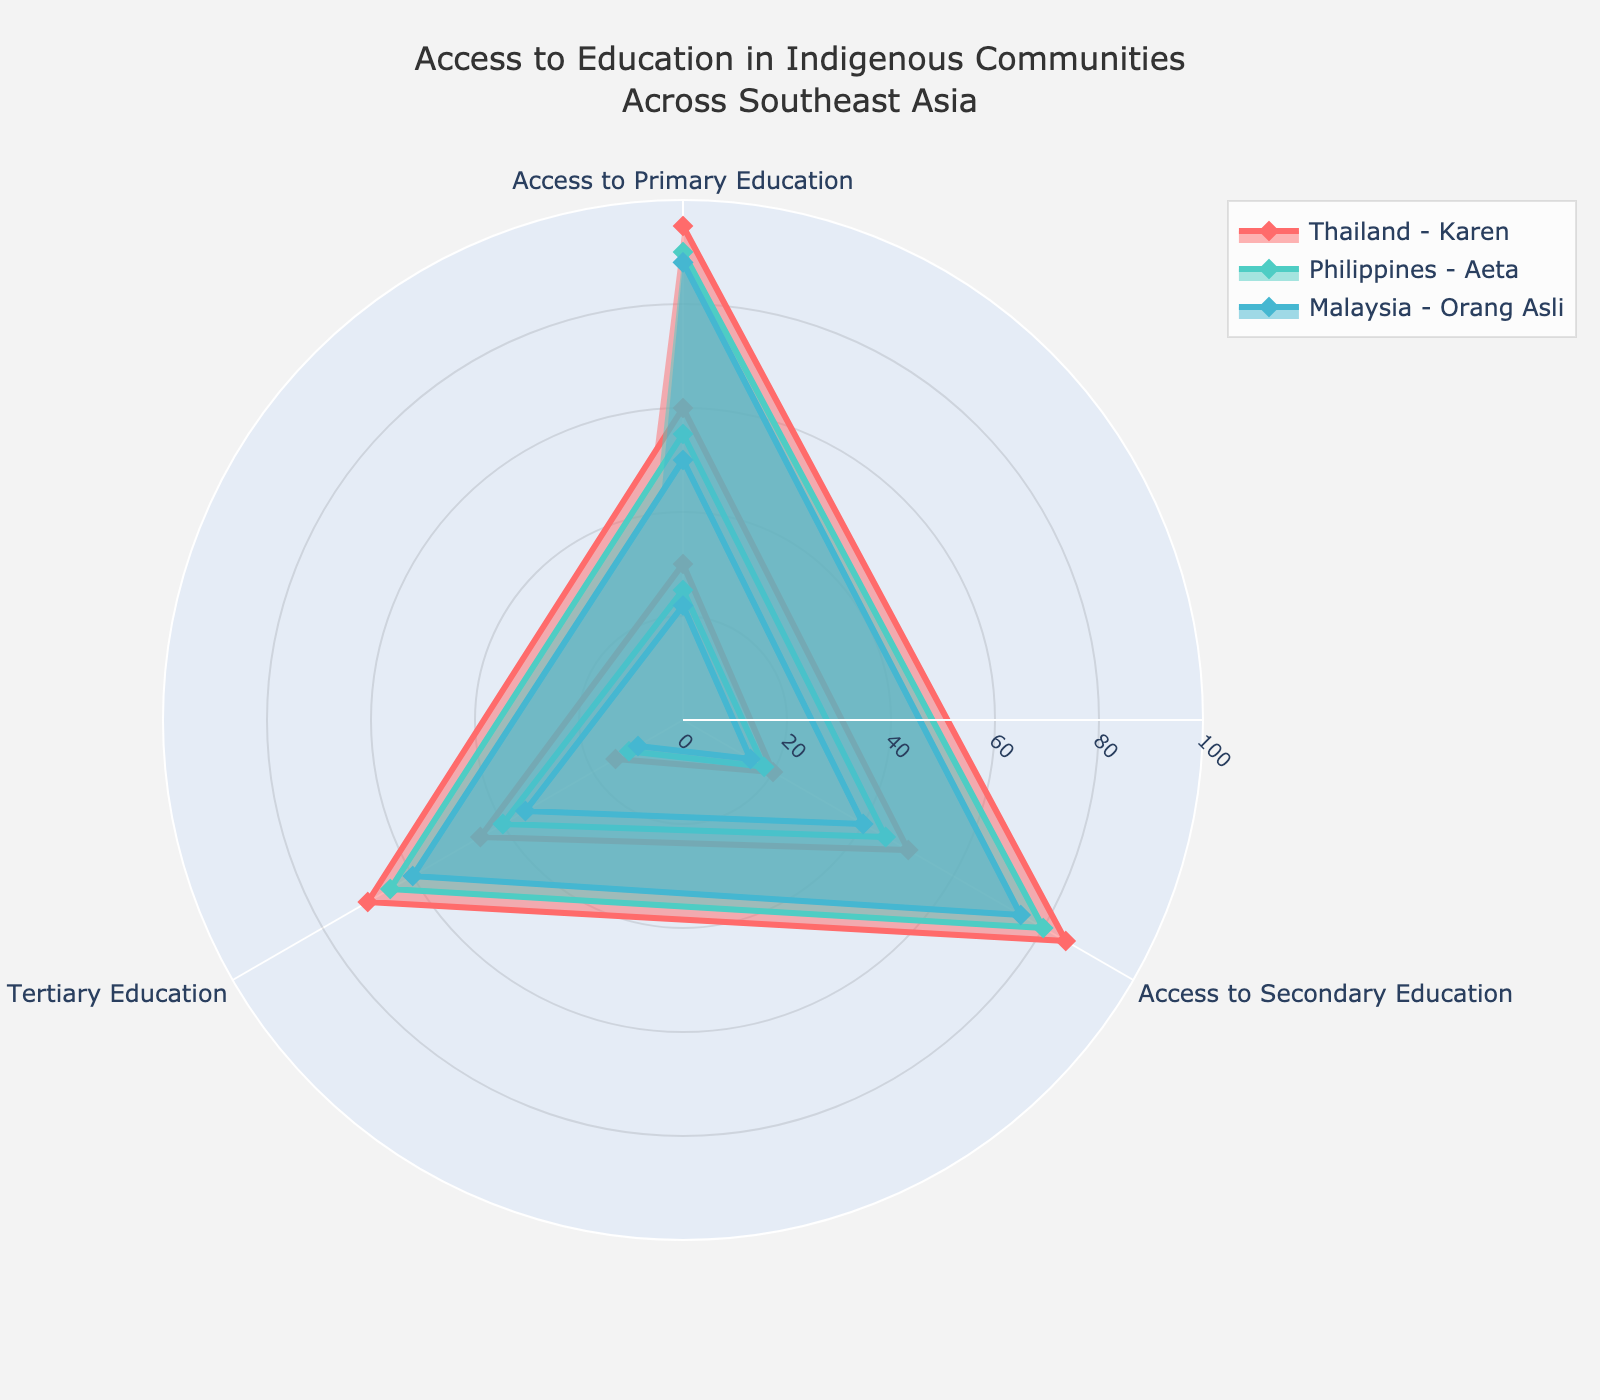What's the title of the figure? The title of the figure is typically found at the top, indicating what the overall subject of the visualization is. This figure's title is "Access to Education in Indigenous Communities Across Southeast Asia."
Answer: Access to Education in Indigenous Communities Across Southeast Asia How many regions are compared in the figure? By examining the legend or the distinct lines representing different groups, we can identify the number of regions. There are three regions being compared: Thailand - Karen, Philippines - Aeta, and Malaysia - Orang Asli.
Answer: Three Which region has the highest rate of men accessing primary education? By looking at the radar plot points for Access to Primary Education under men's education rate, we can see which group is the highest. The highest value is represented by Thailand - Karen at 95%.
Answer: Thailand - Karen What is the difference in the high school completion rate between men and women for the Thailand - Karen region? We'll look at the high school completion rates for men and women in Thailand - Karen. Men have a rate of 70%, and women have 50%. The difference is 70% - 50% = 20%.
Answer: 20% Which education level shows the largest gender disparity in the Malaysia - Orang Asli region? Checking each education level for the Malaysia - Orang Asli region, we calculate the disparity by taking the absolute difference between men's and women's rates: Primary (88% - 75% = 13%), Secondary (50% - 40% = 10%), Tertiary (22% - 15% = 7%). Primary education shows the largest disparity.
Answer: Primary Education For the Philippines - Aeta region, which education level has the highest women's education rate? Observing the women’s education rates in the Philippines - Aeta region for Primary, Secondary, and Tertiary education. The highest value is for Primary Education at 80%.
Answer: Primary Education What is the combined average secondary education rate for both genders in the Malaysia - Orang Asli region? Calculate the secondary education rates for both genders in Malaysia - Orang Asli: (50% for men + 40% for women) / 2 = 45%
Answer: 45% Which region has the highest overall education rate for tertiary education? Compare the tertiary education rates for all regions by examining their values: Thailand - Karen (30% men, 20% women), Philippines - Aeta (25% men, 18% women), Malaysia - Orang Asli (22% men, 15% women). Thailand - Karen has the highest overall education rate for tertiary education.
Answer: Thailand - Karen How much higher is the men’s access to secondary education than women's in the Philippines - Aeta region? Look at the values for secondary education in the Philippines - Aeta region: Men's rate is 55%, women's rate is 45%. The difference is 55% - 45% = 10%.
Answer: 10% Among all regions and categories, which education rate is the lowest and for which gender? Find the lowest education rate in the radar chart by comparing all values. The lowest rate is 10%, which is for women accessing tertiary education in the Malaysia - Orang Asli region.
Answer: Women, Tertiary Education, Malaysia - Orang Asli 